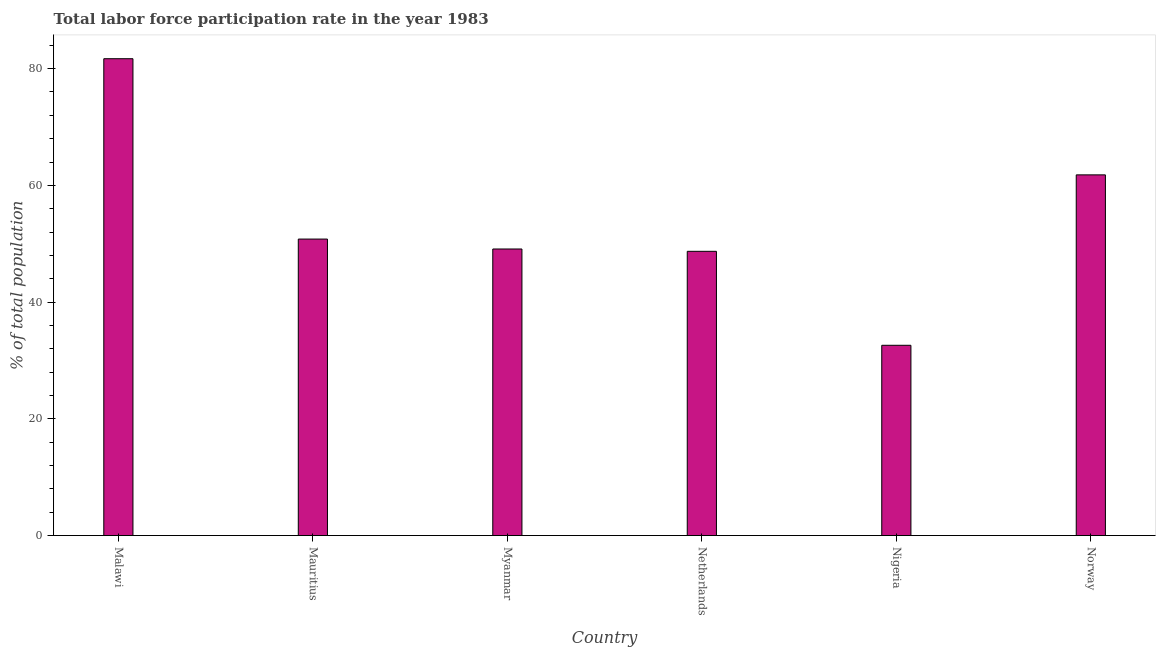Does the graph contain any zero values?
Give a very brief answer. No. What is the title of the graph?
Your answer should be compact. Total labor force participation rate in the year 1983. What is the label or title of the X-axis?
Offer a very short reply. Country. What is the label or title of the Y-axis?
Your response must be concise. % of total population. What is the total labor force participation rate in Norway?
Make the answer very short. 61.8. Across all countries, what is the maximum total labor force participation rate?
Keep it short and to the point. 81.7. Across all countries, what is the minimum total labor force participation rate?
Provide a short and direct response. 32.6. In which country was the total labor force participation rate maximum?
Ensure brevity in your answer.  Malawi. In which country was the total labor force participation rate minimum?
Keep it short and to the point. Nigeria. What is the sum of the total labor force participation rate?
Your answer should be compact. 324.7. What is the difference between the total labor force participation rate in Myanmar and Nigeria?
Offer a terse response. 16.5. What is the average total labor force participation rate per country?
Your answer should be compact. 54.12. What is the median total labor force participation rate?
Offer a very short reply. 49.95. In how many countries, is the total labor force participation rate greater than 16 %?
Keep it short and to the point. 6. What is the ratio of the total labor force participation rate in Malawi to that in Mauritius?
Your answer should be compact. 1.61. Is the total labor force participation rate in Malawi less than that in Myanmar?
Your response must be concise. No. Is the sum of the total labor force participation rate in Netherlands and Nigeria greater than the maximum total labor force participation rate across all countries?
Your answer should be very brief. No. What is the difference between the highest and the lowest total labor force participation rate?
Make the answer very short. 49.1. In how many countries, is the total labor force participation rate greater than the average total labor force participation rate taken over all countries?
Ensure brevity in your answer.  2. How many bars are there?
Your answer should be compact. 6. What is the difference between two consecutive major ticks on the Y-axis?
Offer a very short reply. 20. Are the values on the major ticks of Y-axis written in scientific E-notation?
Give a very brief answer. No. What is the % of total population in Malawi?
Give a very brief answer. 81.7. What is the % of total population of Mauritius?
Your answer should be compact. 50.8. What is the % of total population in Myanmar?
Your response must be concise. 49.1. What is the % of total population in Netherlands?
Keep it short and to the point. 48.7. What is the % of total population in Nigeria?
Keep it short and to the point. 32.6. What is the % of total population of Norway?
Offer a very short reply. 61.8. What is the difference between the % of total population in Malawi and Mauritius?
Your answer should be compact. 30.9. What is the difference between the % of total population in Malawi and Myanmar?
Ensure brevity in your answer.  32.6. What is the difference between the % of total population in Malawi and Nigeria?
Ensure brevity in your answer.  49.1. What is the difference between the % of total population in Mauritius and Myanmar?
Your response must be concise. 1.7. What is the difference between the % of total population in Mauritius and Netherlands?
Your answer should be very brief. 2.1. What is the difference between the % of total population in Myanmar and Norway?
Your answer should be very brief. -12.7. What is the difference between the % of total population in Netherlands and Nigeria?
Offer a very short reply. 16.1. What is the difference between the % of total population in Nigeria and Norway?
Offer a terse response. -29.2. What is the ratio of the % of total population in Malawi to that in Mauritius?
Offer a terse response. 1.61. What is the ratio of the % of total population in Malawi to that in Myanmar?
Ensure brevity in your answer.  1.66. What is the ratio of the % of total population in Malawi to that in Netherlands?
Your answer should be compact. 1.68. What is the ratio of the % of total population in Malawi to that in Nigeria?
Your response must be concise. 2.51. What is the ratio of the % of total population in Malawi to that in Norway?
Give a very brief answer. 1.32. What is the ratio of the % of total population in Mauritius to that in Myanmar?
Provide a succinct answer. 1.03. What is the ratio of the % of total population in Mauritius to that in Netherlands?
Ensure brevity in your answer.  1.04. What is the ratio of the % of total population in Mauritius to that in Nigeria?
Make the answer very short. 1.56. What is the ratio of the % of total population in Mauritius to that in Norway?
Provide a succinct answer. 0.82. What is the ratio of the % of total population in Myanmar to that in Nigeria?
Provide a succinct answer. 1.51. What is the ratio of the % of total population in Myanmar to that in Norway?
Ensure brevity in your answer.  0.79. What is the ratio of the % of total population in Netherlands to that in Nigeria?
Your response must be concise. 1.49. What is the ratio of the % of total population in Netherlands to that in Norway?
Your answer should be very brief. 0.79. What is the ratio of the % of total population in Nigeria to that in Norway?
Offer a terse response. 0.53. 